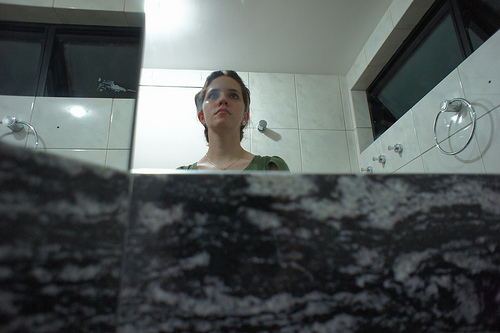<image>
Is the person on the mirror? No. The person is not positioned on the mirror. They may be near each other, but the person is not supported by or resting on top of the mirror. Is the woman in the washroom? Yes. The woman is contained within or inside the washroom, showing a containment relationship. 